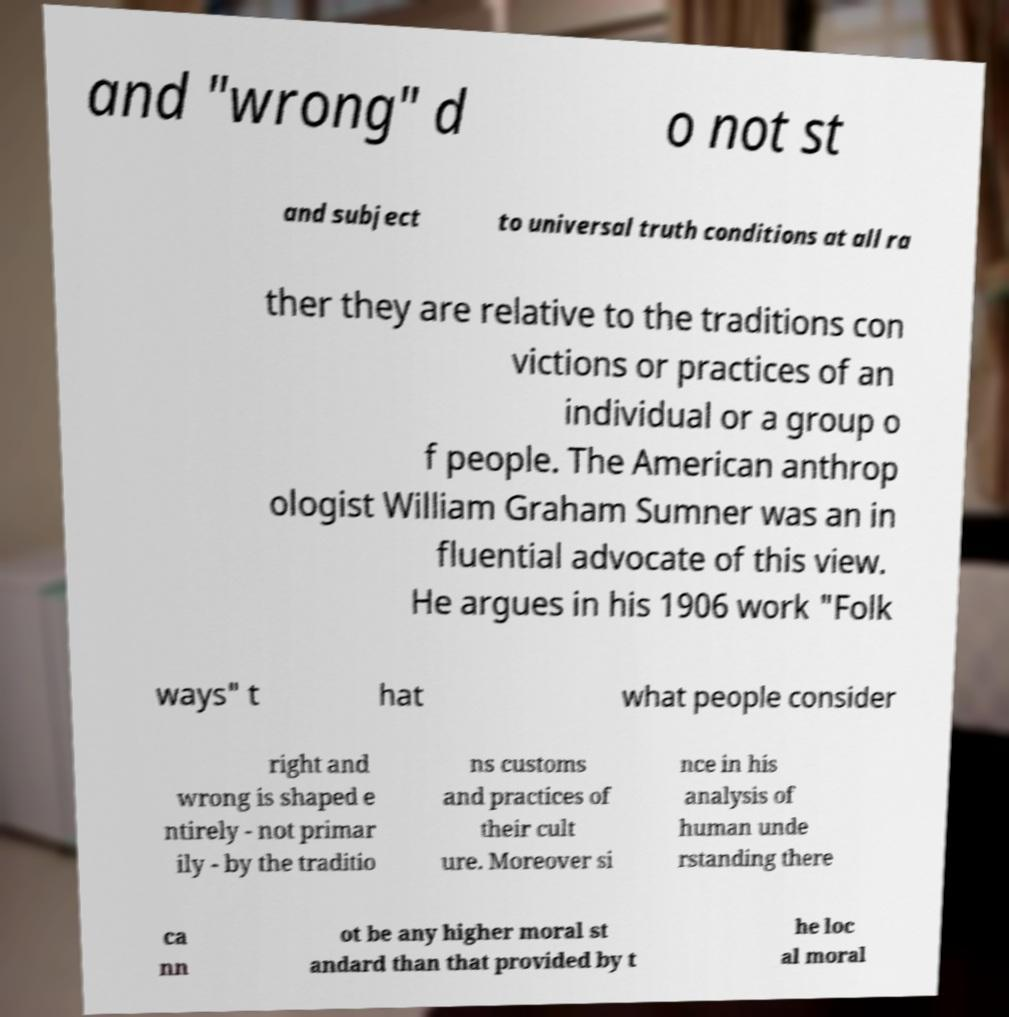Please read and relay the text visible in this image. What does it say? and "wrong" d o not st and subject to universal truth conditions at all ra ther they are relative to the traditions con victions or practices of an individual or a group o f people. The American anthrop ologist William Graham Sumner was an in fluential advocate of this view. He argues in his 1906 work "Folk ways" t hat what people consider right and wrong is shaped e ntirely - not primar ily - by the traditio ns customs and practices of their cult ure. Moreover si nce in his analysis of human unde rstanding there ca nn ot be any higher moral st andard than that provided by t he loc al moral 